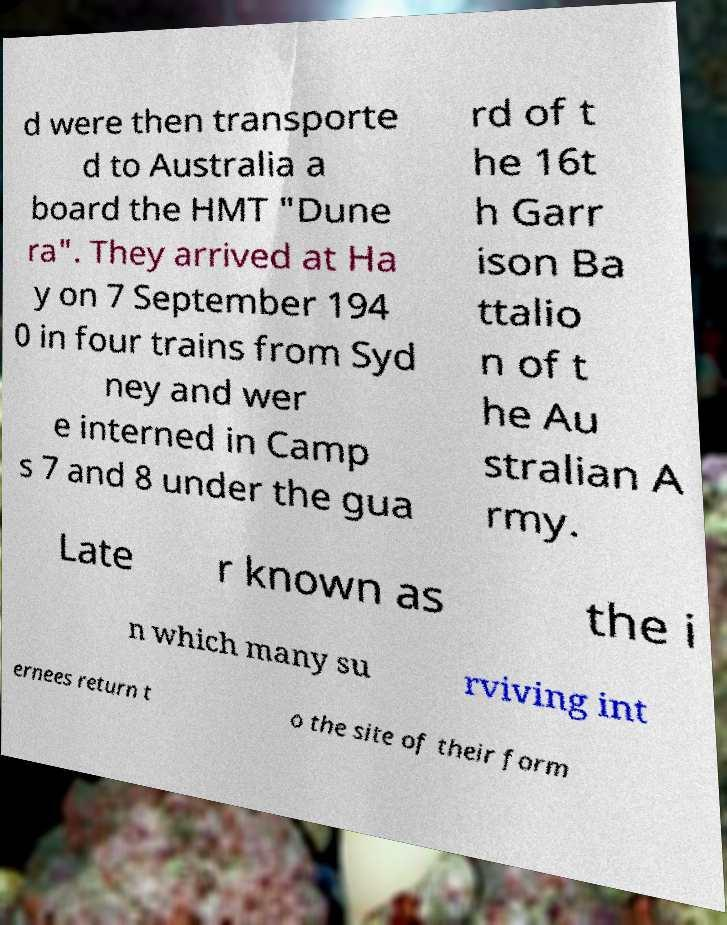Can you accurately transcribe the text from the provided image for me? d were then transporte d to Australia a board the HMT "Dune ra". They arrived at Ha y on 7 September 194 0 in four trains from Syd ney and wer e interned in Camp s 7 and 8 under the gua rd of t he 16t h Garr ison Ba ttalio n of t he Au stralian A rmy. Late r known as the i n which many su rviving int ernees return t o the site of their form 